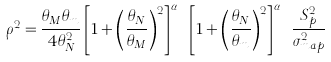<formula> <loc_0><loc_0><loc_500><loc_500>\rho ^ { 2 } = \frac { \theta _ { M } \theta _ { m } } { 4 \theta _ { N } ^ { 2 } } \left [ 1 + \left ( \frac { \theta _ { N } } { \theta _ { M } } \right ) ^ { 2 } \right ] ^ { \alpha _ { M } } \left [ 1 + \left ( \frac { \theta _ { N } } { \theta _ { m } } \right ) ^ { 2 } \right ] ^ { \alpha _ { m } } \frac { S _ { p } ^ { 2 } } { \sigma _ { m a p } ^ { 2 } }</formula> 